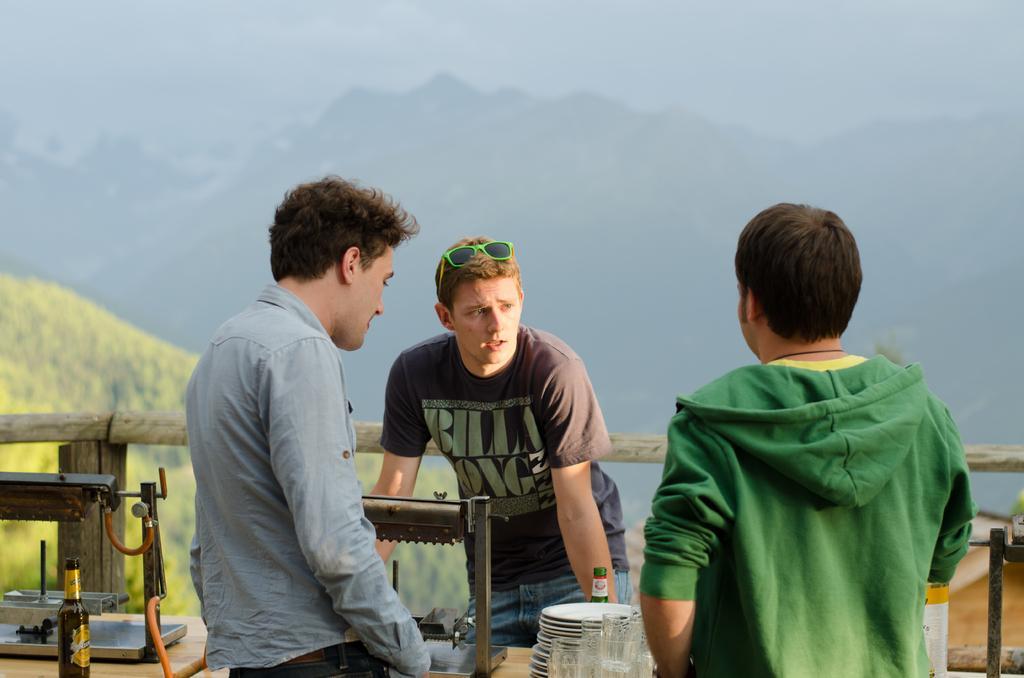Could you give a brief overview of what you see in this image? In this image I see 3 men and few plates, glasses and 2 bottles over here. I can also see an equipment. 